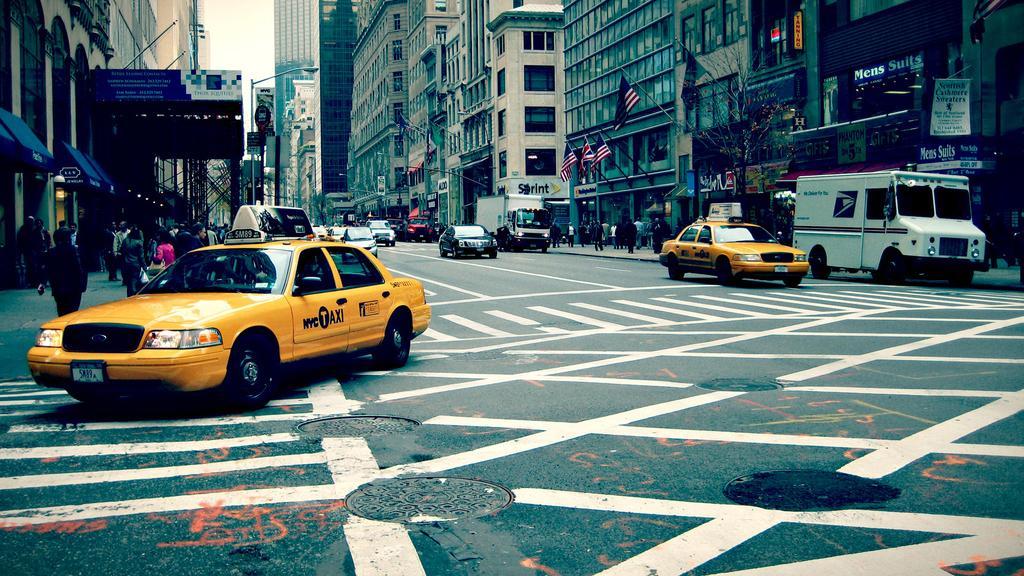Describe this image in one or two sentences. In this image we can see cars travelling on the road, here is the vehicle, here are the flags, here are the buildings, here is the street light, at above here is the sky. 